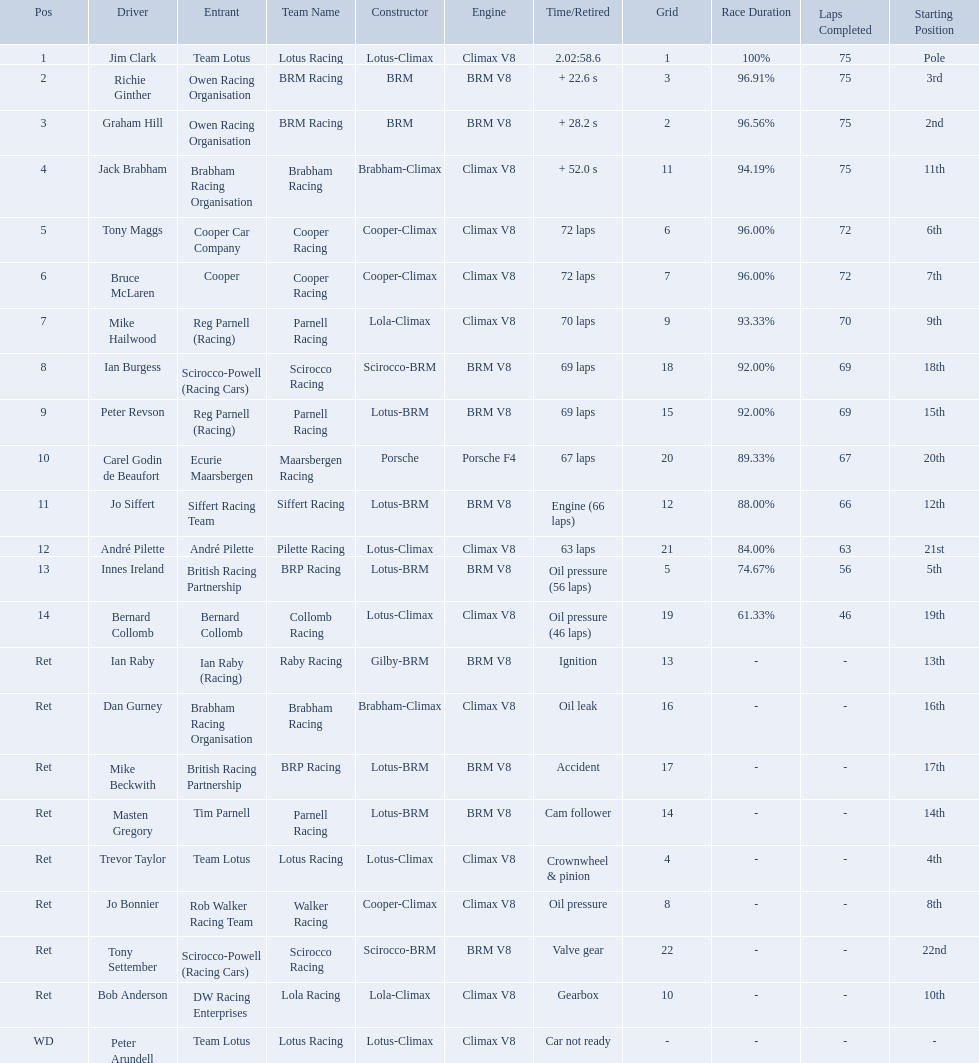Who are all the drivers? Jim Clark, Richie Ginther, Graham Hill, Jack Brabham, Tony Maggs, Bruce McLaren, Mike Hailwood, Ian Burgess, Peter Revson, Carel Godin de Beaufort, Jo Siffert, André Pilette, Innes Ireland, Bernard Collomb, Ian Raby, Dan Gurney, Mike Beckwith, Masten Gregory, Trevor Taylor, Jo Bonnier, Tony Settember, Bob Anderson, Peter Arundell. What position were they in? 1, 2, 3, 4, 5, 6, 7, 8, 9, 10, 11, 12, 13, 14, Ret, Ret, Ret, Ret, Ret, Ret, Ret, Ret, WD. What about just tony maggs and jo siffert? 5, 11. And between them, which driver came in earlier? Tony Maggs. Who are all the drivers? Jim Clark, Richie Ginther, Graham Hill, Jack Brabham, Tony Maggs, Bruce McLaren, Mike Hailwood, Ian Burgess, Peter Revson, Carel Godin de Beaufort, Jo Siffert, André Pilette, Innes Ireland, Bernard Collomb, Ian Raby, Dan Gurney, Mike Beckwith, Masten Gregory, Trevor Taylor, Jo Bonnier, Tony Settember, Bob Anderson, Peter Arundell. What were their positions? 1, 2, 3, 4, 5, 6, 7, 8, 9, 10, 11, 12, 13, 14, Ret, Ret, Ret, Ret, Ret, Ret, Ret, Ret, WD. What are all the constructor names? Lotus-Climax, BRM, BRM, Brabham-Climax, Cooper-Climax, Cooper-Climax, Lola-Climax, Scirocco-BRM, Lotus-BRM, Porsche, Lotus-BRM, Lotus-Climax, Lotus-BRM, Lotus-Climax, Gilby-BRM, Brabham-Climax, Lotus-BRM, Lotus-BRM, Lotus-Climax, Cooper-Climax, Scirocco-BRM, Lola-Climax, Lotus-Climax. And which drivers drove a cooper-climax? Tony Maggs, Bruce McLaren. Between those tow, who was positioned higher? Tony Maggs. Who were the drivers in the the 1963 international gold cup? Jim Clark, Richie Ginther, Graham Hill, Jack Brabham, Tony Maggs, Bruce McLaren, Mike Hailwood, Ian Burgess, Peter Revson, Carel Godin de Beaufort, Jo Siffert, André Pilette, Innes Ireland, Bernard Collomb, Ian Raby, Dan Gurney, Mike Beckwith, Masten Gregory, Trevor Taylor, Jo Bonnier, Tony Settember, Bob Anderson, Peter Arundell. Which drivers drove a cooper-climax car? Tony Maggs, Bruce McLaren, Jo Bonnier. Would you mind parsing the complete table? {'header': ['Pos', 'Driver', 'Entrant', 'Team Name', 'Constructor', 'Engine', 'Time/Retired', 'Grid', 'Race Duration', 'Laps Completed', 'Starting Position'], 'rows': [['1', 'Jim Clark', 'Team Lotus', 'Lotus Racing', 'Lotus-Climax', 'Climax V8', '2.02:58.6', '1', '100%', '75', 'Pole'], ['2', 'Richie Ginther', 'Owen Racing Organisation', 'BRM Racing', 'BRM', 'BRM V8', '+ 22.6 s', '3', '96.91%', '75', '3rd'], ['3', 'Graham Hill', 'Owen Racing Organisation', 'BRM Racing', 'BRM', 'BRM V8', '+ 28.2 s', '2', '96.56%', '75', '2nd'], ['4', 'Jack Brabham', 'Brabham Racing Organisation', 'Brabham Racing', 'Brabham-Climax', 'Climax V8', '+ 52.0 s', '11', '94.19%', '75', '11th'], ['5', 'Tony Maggs', 'Cooper Car Company', 'Cooper Racing', 'Cooper-Climax', 'Climax V8', '72 laps', '6', '96.00%', '72', '6th'], ['6', 'Bruce McLaren', 'Cooper', 'Cooper Racing', 'Cooper-Climax', 'Climax V8', '72 laps', '7', '96.00%', '72', '7th'], ['7', 'Mike Hailwood', 'Reg Parnell (Racing)', 'Parnell Racing', 'Lola-Climax', 'Climax V8', '70 laps', '9', '93.33%', '70', '9th'], ['8', 'Ian Burgess', 'Scirocco-Powell (Racing Cars)', 'Scirocco Racing', 'Scirocco-BRM', 'BRM V8', '69 laps', '18', '92.00%', '69', '18th'], ['9', 'Peter Revson', 'Reg Parnell (Racing)', 'Parnell Racing', 'Lotus-BRM', 'BRM V8', '69 laps', '15', '92.00%', '69', '15th'], ['10', 'Carel Godin de Beaufort', 'Ecurie Maarsbergen', 'Maarsbergen Racing', 'Porsche', 'Porsche F4', '67 laps', '20', '89.33%', '67', '20th'], ['11', 'Jo Siffert', 'Siffert Racing Team', 'Siffert Racing', 'Lotus-BRM', 'BRM V8', 'Engine (66 laps)', '12', '88.00%', '66', '12th'], ['12', 'André Pilette', 'André Pilette', 'Pilette Racing', 'Lotus-Climax', 'Climax V8', '63 laps', '21', '84.00%', '63', '21st'], ['13', 'Innes Ireland', 'British Racing Partnership', 'BRP Racing', 'Lotus-BRM', 'BRM V8', 'Oil pressure (56 laps)', '5', '74.67%', '56', '5th'], ['14', 'Bernard Collomb', 'Bernard Collomb', 'Collomb Racing', 'Lotus-Climax', 'Climax V8', 'Oil pressure (46 laps)', '19', '61.33%', '46', '19th'], ['Ret', 'Ian Raby', 'Ian Raby (Racing)', 'Raby Racing', 'Gilby-BRM', 'BRM V8', 'Ignition', '13', '-', '-', '13th'], ['Ret', 'Dan Gurney', 'Brabham Racing Organisation', 'Brabham Racing', 'Brabham-Climax', 'Climax V8', 'Oil leak', '16', '-', '-', '16th'], ['Ret', 'Mike Beckwith', 'British Racing Partnership', 'BRP Racing', 'Lotus-BRM', 'BRM V8', 'Accident', '17', '-', '-', '17th'], ['Ret', 'Masten Gregory', 'Tim Parnell', 'Parnell Racing', 'Lotus-BRM', 'BRM V8', 'Cam follower', '14', '-', '-', '14th'], ['Ret', 'Trevor Taylor', 'Team Lotus', 'Lotus Racing', 'Lotus-Climax', 'Climax V8', 'Crownwheel & pinion', '4', '-', '-', '4th'], ['Ret', 'Jo Bonnier', 'Rob Walker Racing Team', 'Walker Racing', 'Cooper-Climax', 'Climax V8', 'Oil pressure', '8', '-', '-', '8th'], ['Ret', 'Tony Settember', 'Scirocco-Powell (Racing Cars)', 'Scirocco Racing', 'Scirocco-BRM', 'BRM V8', 'Valve gear', '22', '-', '-', '22nd'], ['Ret', 'Bob Anderson', 'DW Racing Enterprises', 'Lola Racing', 'Lola-Climax', 'Climax V8', 'Gearbox', '10', '-', '-', '10th'], ['WD', 'Peter Arundell', 'Team Lotus', 'Lotus Racing', 'Lotus-Climax', 'Climax V8', 'Car not ready', '-', '-', '-', '-']]} What did these drivers place? 5, 6, Ret. What was the best placing position? 5. Who was the driver with this placing? Tony Maggs. Who were the two that that a similar problem? Innes Ireland. What was their common problem? Oil pressure. Who drove in the 1963 international gold cup? Jim Clark, Richie Ginther, Graham Hill, Jack Brabham, Tony Maggs, Bruce McLaren, Mike Hailwood, Ian Burgess, Peter Revson, Carel Godin de Beaufort, Jo Siffert, André Pilette, Innes Ireland, Bernard Collomb, Ian Raby, Dan Gurney, Mike Beckwith, Masten Gregory, Trevor Taylor, Jo Bonnier, Tony Settember, Bob Anderson, Peter Arundell. Who had problems during the race? Jo Siffert, Innes Ireland, Bernard Collomb, Ian Raby, Dan Gurney, Mike Beckwith, Masten Gregory, Trevor Taylor, Jo Bonnier, Tony Settember, Bob Anderson, Peter Arundell. Of those who was still able to finish the race? Jo Siffert, Innes Ireland, Bernard Collomb. Of those who faced the same issue? Innes Ireland, Bernard Collomb. What issue did they have? Oil pressure. 